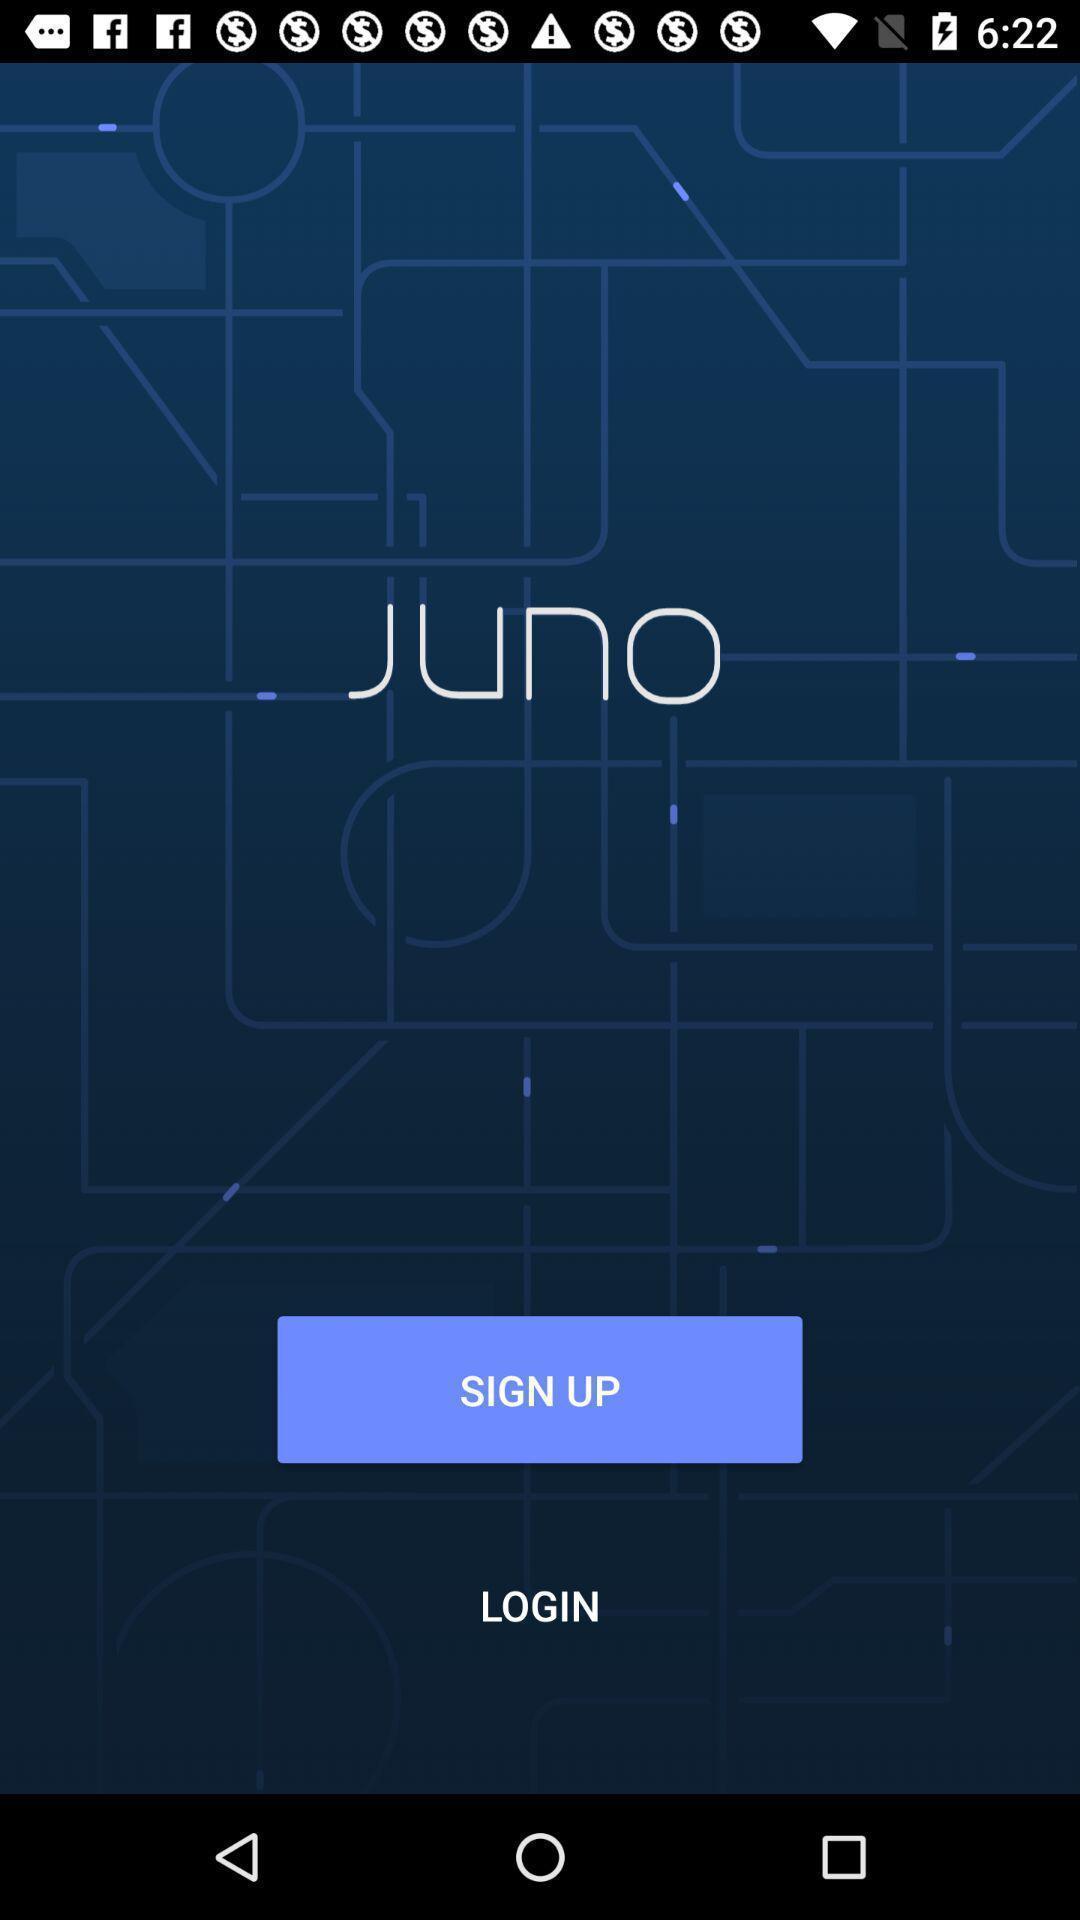Tell me about the visual elements in this screen capture. Sign up/log in page. 